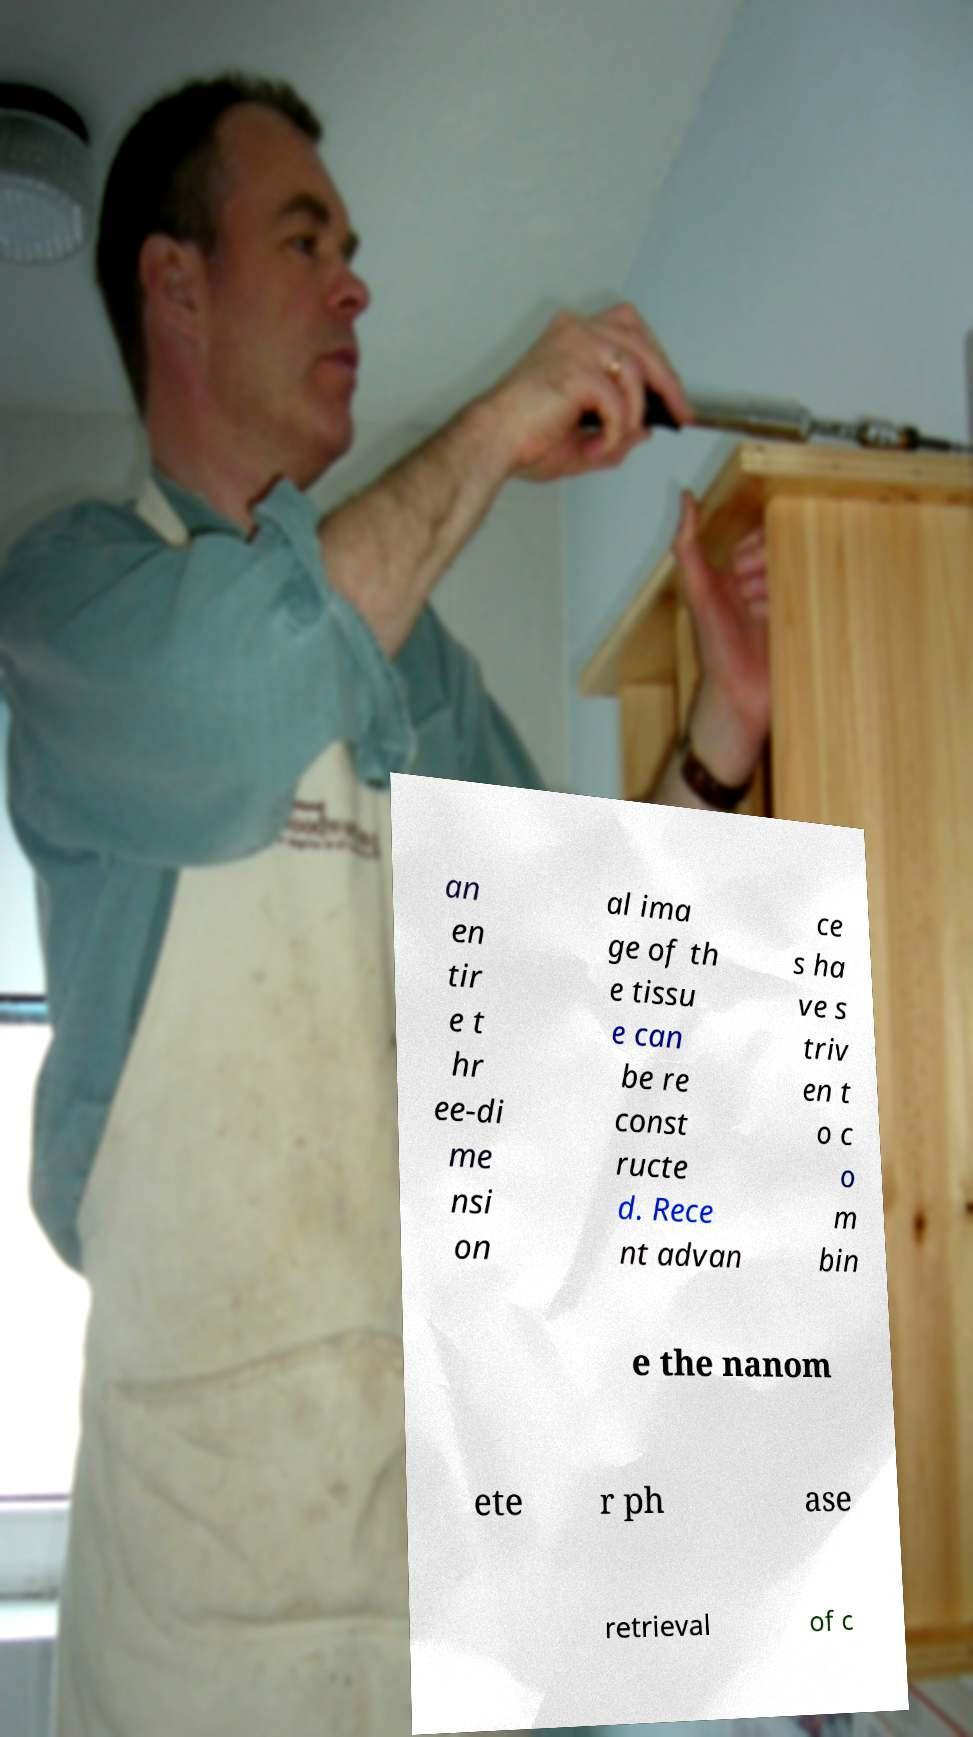Can you accurately transcribe the text from the provided image for me? an en tir e t hr ee-di me nsi on al ima ge of th e tissu e can be re const ructe d. Rece nt advan ce s ha ve s triv en t o c o m bin e the nanom ete r ph ase retrieval of c 